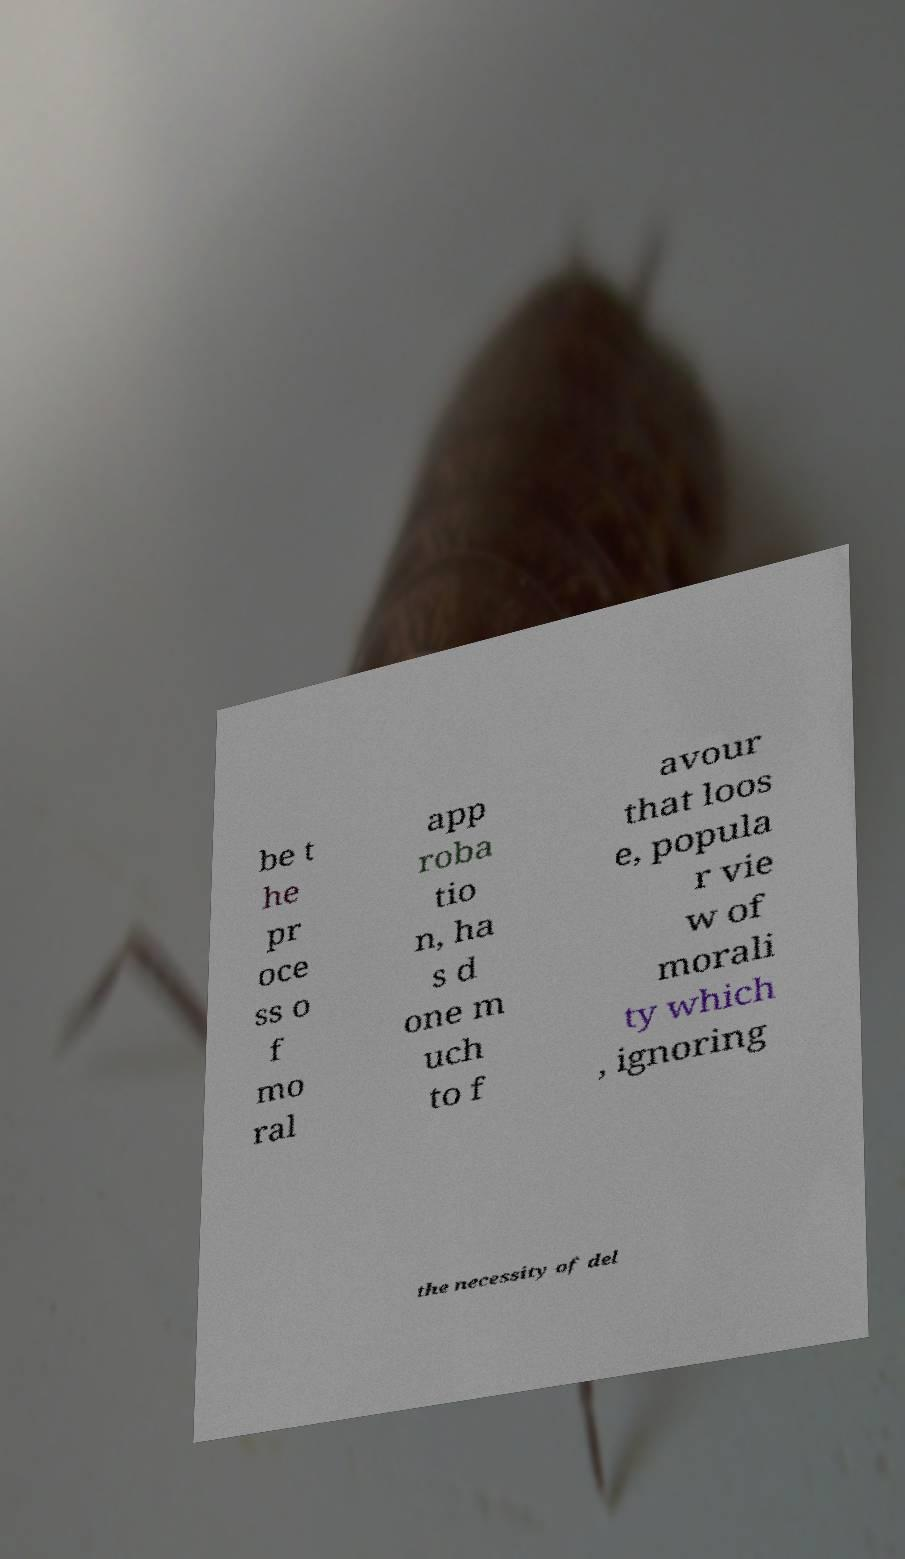What messages or text are displayed in this image? I need them in a readable, typed format. be t he pr oce ss o f mo ral app roba tio n, ha s d one m uch to f avour that loos e, popula r vie w of morali ty which , ignoring the necessity of del 